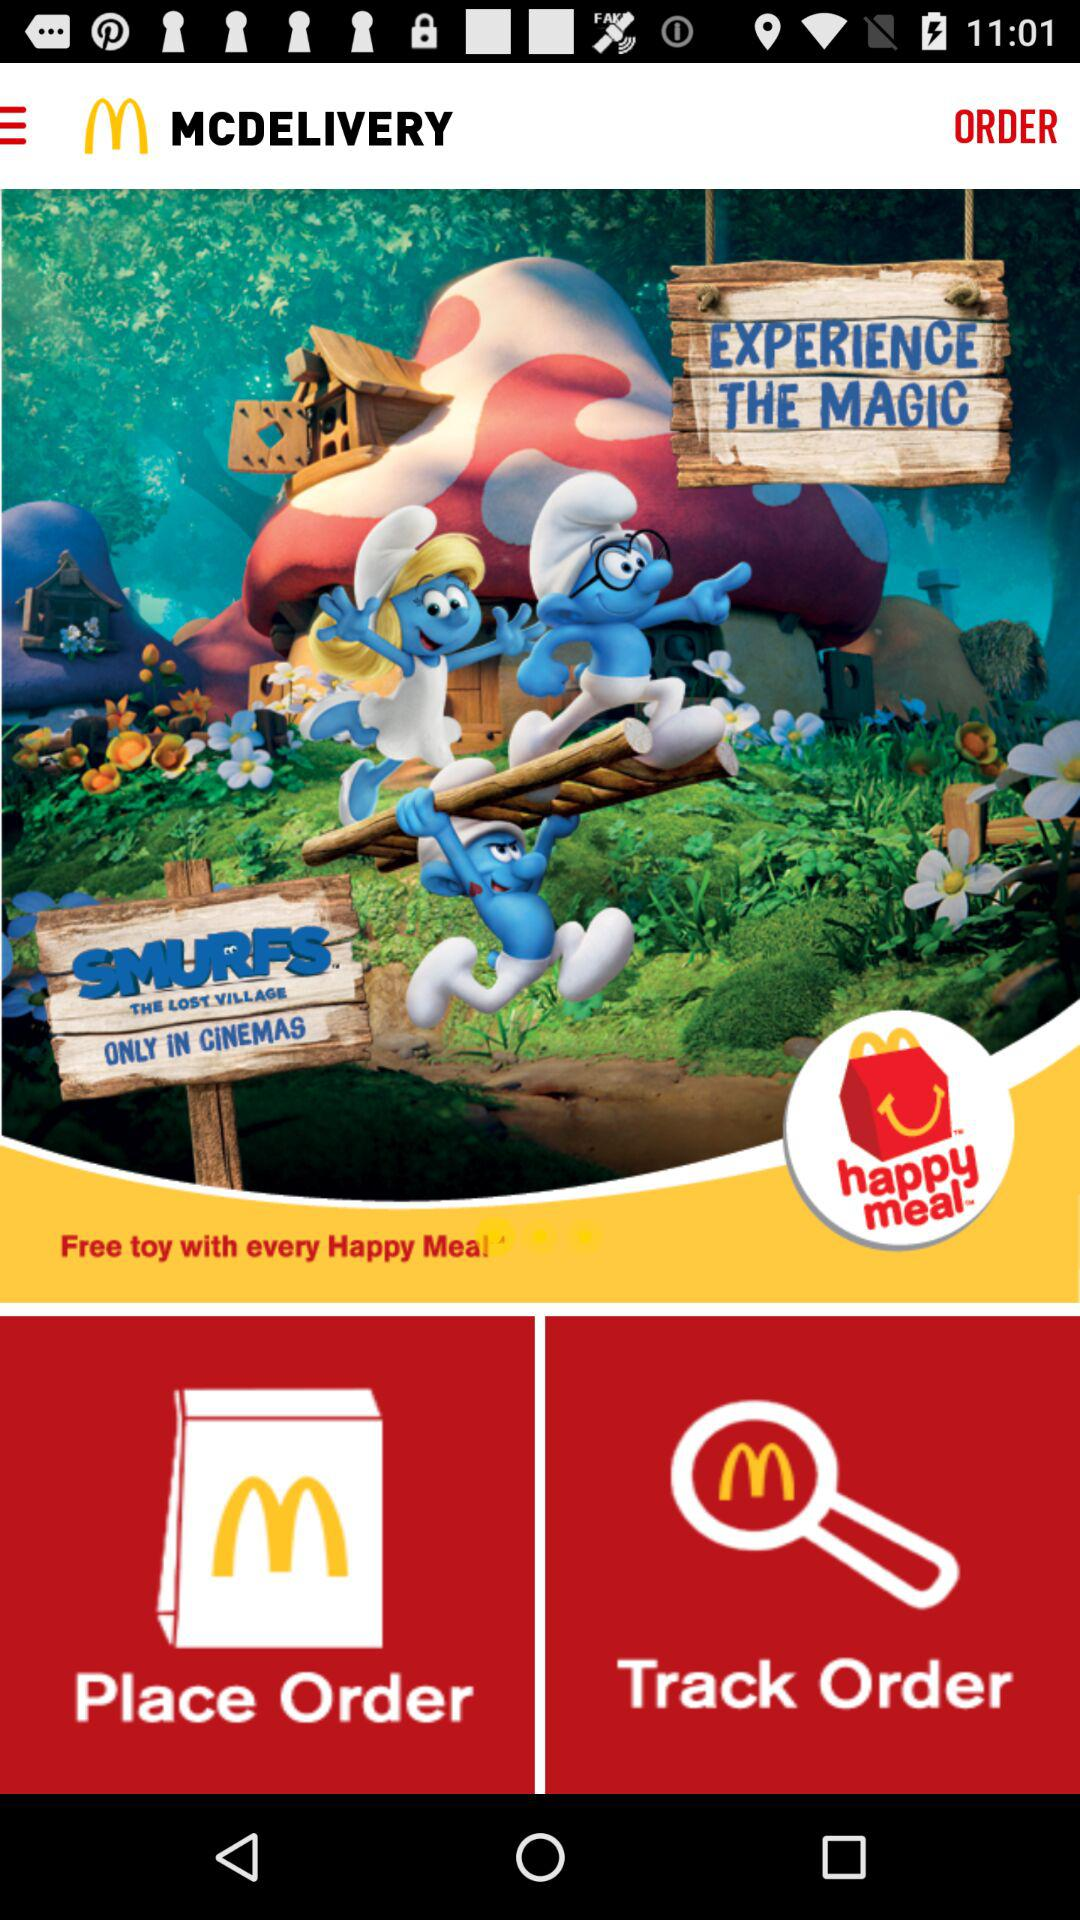What is the cost of a "happy meal"?
When the provided information is insufficient, respond with <no answer>. <no answer> 